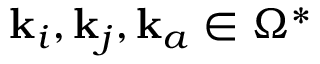<formula> <loc_0><loc_0><loc_500><loc_500>k _ { i } , k _ { j } , k _ { a } \in \Omega ^ { * }</formula> 